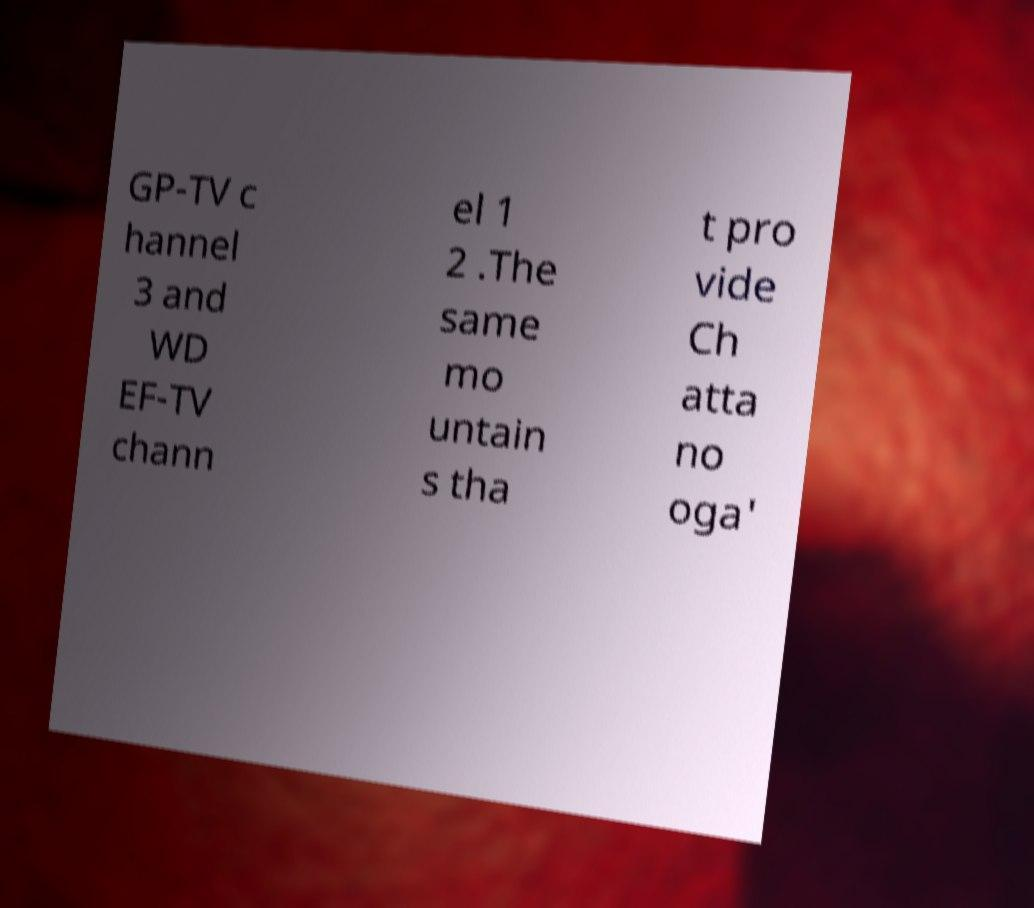I need the written content from this picture converted into text. Can you do that? GP-TV c hannel 3 and WD EF-TV chann el 1 2 .The same mo untain s tha t pro vide Ch atta no oga' 